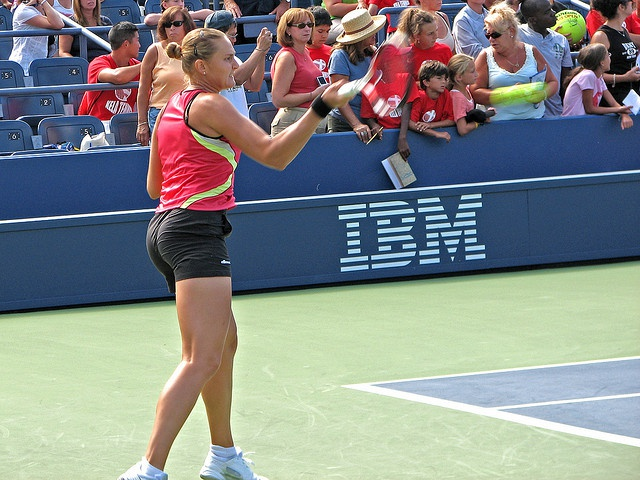Describe the objects in this image and their specific colors. I can see people in gray, black, brown, and ivory tones, people in blue, black, brown, and gray tones, people in gray, brown, and white tones, people in gray, brown, and maroon tones, and people in gray, black, and white tones in this image. 